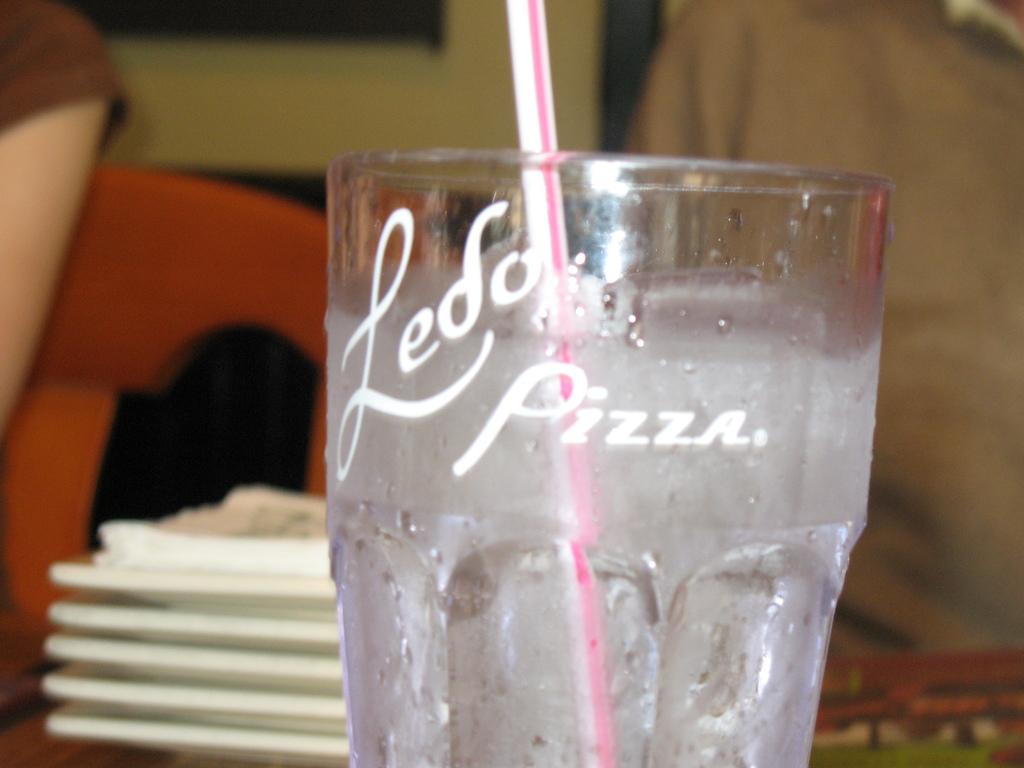What type of food does ledo's sell?
Your answer should be compact. Pizza. What is the name of this restaurant?
Make the answer very short. Ledo pizza. 